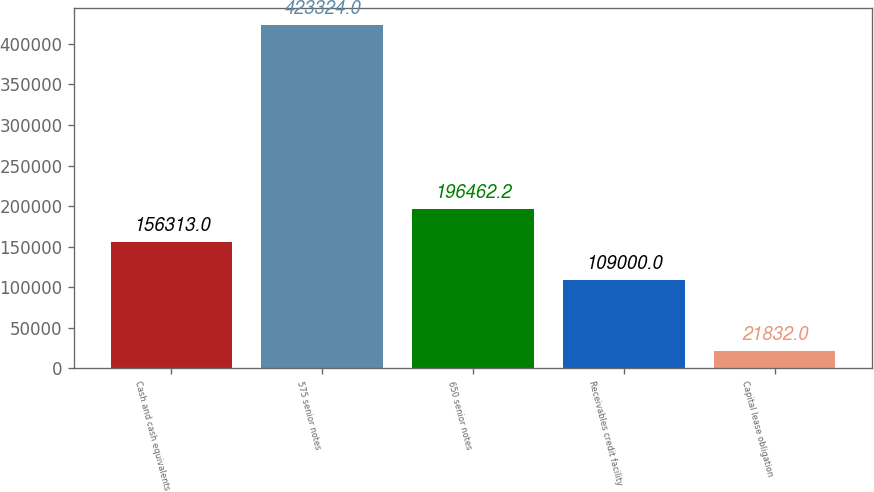<chart> <loc_0><loc_0><loc_500><loc_500><bar_chart><fcel>Cash and cash equivalents<fcel>575 senior notes<fcel>650 senior notes<fcel>Receivables credit facility<fcel>Capital lease obligation<nl><fcel>156313<fcel>423324<fcel>196462<fcel>109000<fcel>21832<nl></chart> 